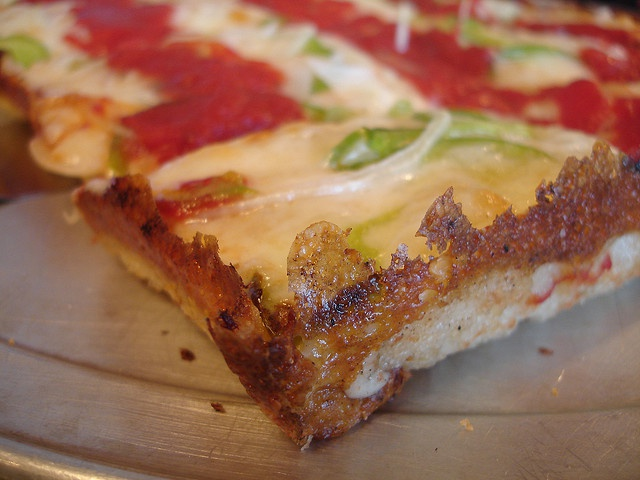Describe the objects in this image and their specific colors. I can see a pizza in salmon, brown, tan, and maroon tones in this image. 